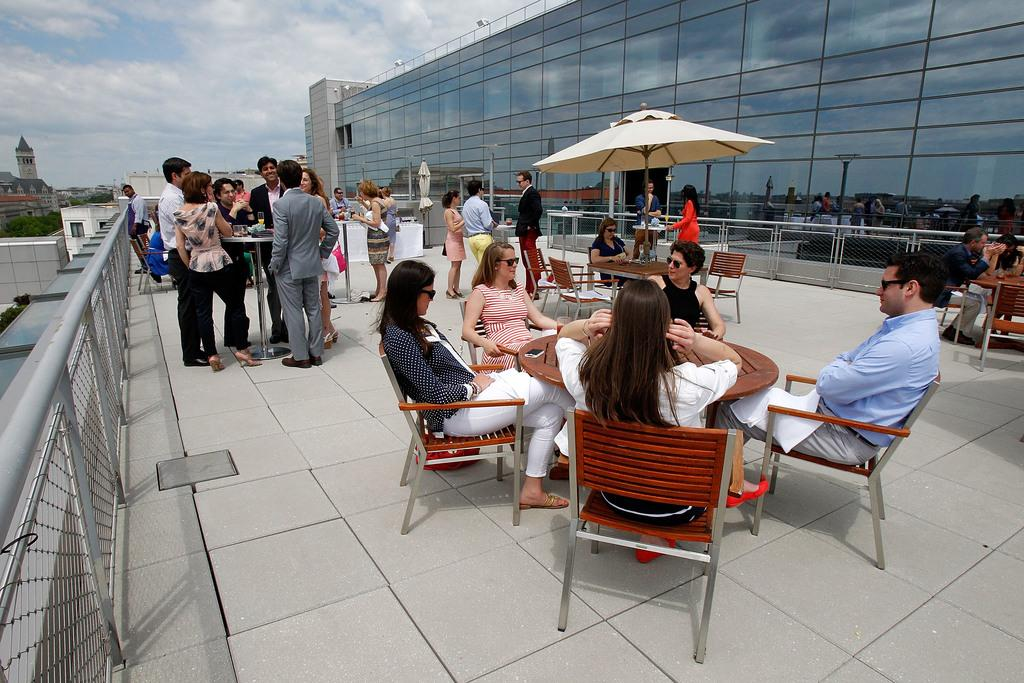How many people are in the image? There are people in the image, but the exact number is not specified. What are some of the people doing in the image? Some people are standing, and some are sitting on chairs. What structures can be seen in the image? There are buildings in the image. What type of natural elements are present in the image? There are trees in the image. What part of the natural environment is visible in the image? The sky is visible in the image. What type of alarm is ringing in the image? There is no alarm present in the image. What shape is the square in the image? There is no square present in the image. 